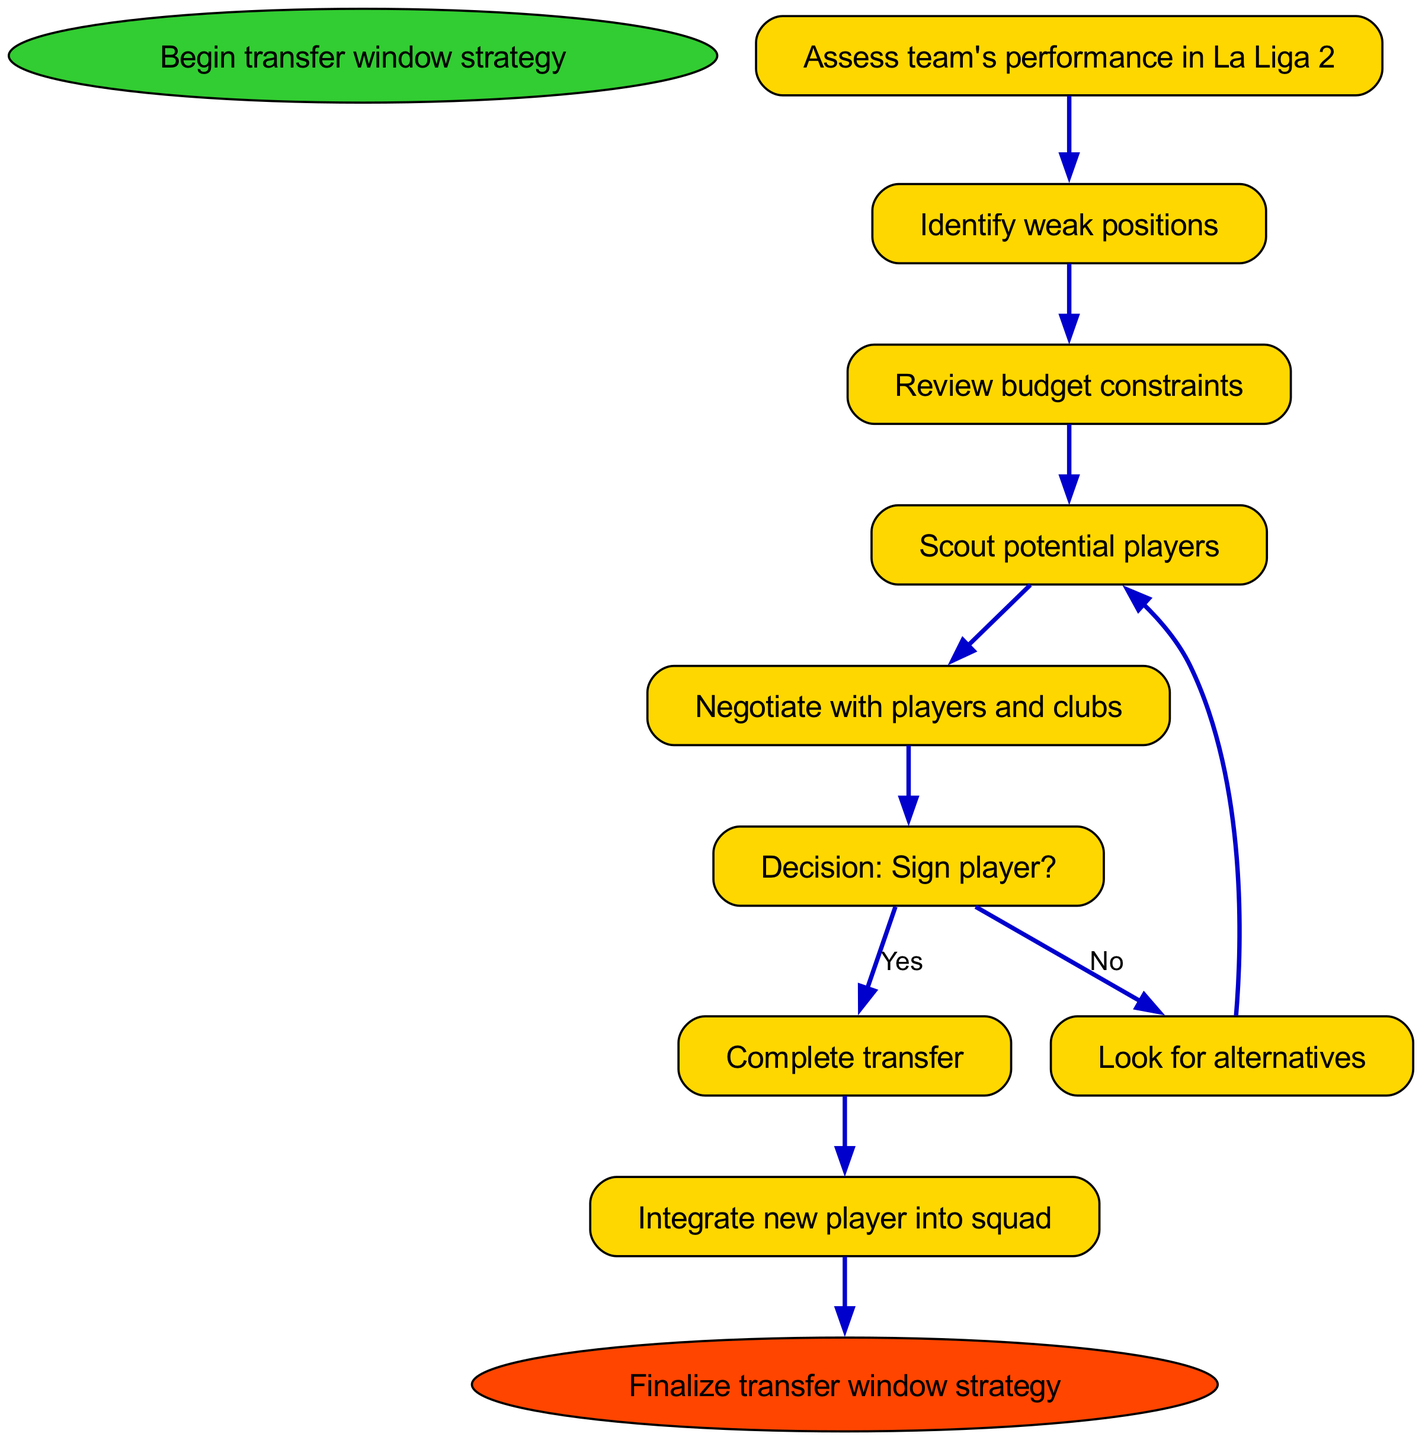What is the starting node of the diagram? The starting node of the diagram is explicitly labeled as "Begin transfer window strategy". It is the first and only starting point before any other processes begin.
Answer: Begin transfer window strategy What is the last action taken before finalizing the transfer strategy? The last action taken before finalizing the transfer strategy is "Integrate new player into squad". This node comes right before the end node of the diagram.
Answer: Integrate new player into squad How many nodes are present in the diagram? The diagram includes a total of 10 nodes, counting both the starting and ending nodes along with the intermediary steps.
Answer: 10 What decision must be made after negotiating with players and clubs? After negotiating with players and clubs, the decision to be made is whether to "Sign player?". This is a crucial decision point that branches the flow of the diagram.
Answer: Sign player? What happens if the decision to sign a player is "No"? If the decision to sign a player is "No", the next step is to "Look for alternatives", which will then loop back to scouting potential players again for further options.
Answer: Look for alternatives What action follows the completion of a transfer? Following the completion of a transfer, the subsequent action is to "Integrate new player into squad". This indicates the next step in ensuring the player is included within the team.
Answer: Integrate new player into squad What is assessed before identifying weak positions? Before identifying weak positions, the team's performance in La Liga 2 is assessed. This step evaluates how well the team has been doing, serving as a foundation for the next phase.
Answer: Assess team's performance in La Liga 2 How does the diagram indicate the negotiation process? The diagram indicates the negotiation process through the node labeled "Negotiate with players and clubs". This step is a direct continuation from scouting potential players and leads to a decision-making branch.
Answer: Negotiate with players and clubs What are the two possible outcomes after the decision to sign a player? The two possible outcomes after the decision to sign a player are to either "Complete transfer" if the answer is yes, or "Look for alternatives" if the answer is no. These options steer the subsequent actions in the process.
Answer: Complete transfer or Look for alternatives 